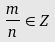<formula> <loc_0><loc_0><loc_500><loc_500>\frac { m } { n } \in Z</formula> 